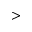<formula> <loc_0><loc_0><loc_500><loc_500>{ > }</formula> 